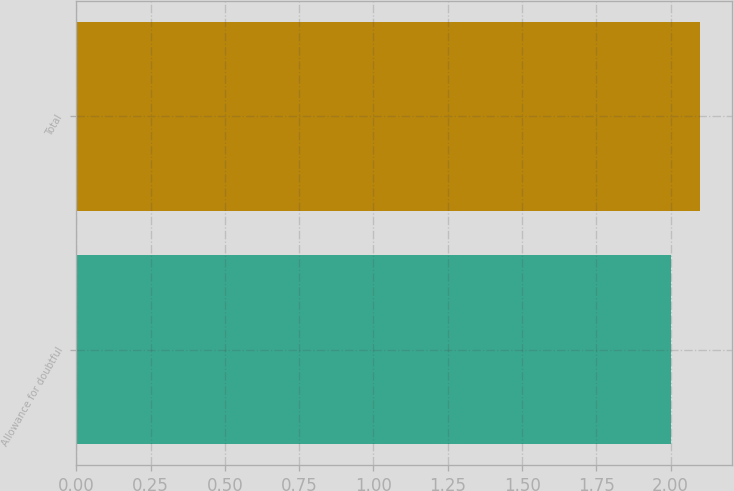Convert chart to OTSL. <chart><loc_0><loc_0><loc_500><loc_500><bar_chart><fcel>Allowance for doubtful<fcel>Total<nl><fcel>2<fcel>2.1<nl></chart> 